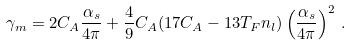Convert formula to latex. <formula><loc_0><loc_0><loc_500><loc_500>\gamma _ { m } = 2 C _ { A } \frac { \alpha _ { s } } { 4 \pi } + \frac { 4 } { 9 } C _ { A } ( 1 7 C _ { A } - 1 3 T _ { F } n _ { l } ) \left ( \frac { \alpha _ { s } } { 4 \pi } \right ) ^ { 2 } \, .</formula> 